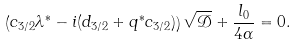<formula> <loc_0><loc_0><loc_500><loc_500>\left ( c _ { 3 / 2 } \lambda ^ { * } - i ( d _ { 3 / 2 } + q ^ { * } c _ { 3 / 2 } ) \right ) \sqrt { \mathcal { D } } + \frac { l _ { 0 } } { 4 \alpha } = 0 .</formula> 